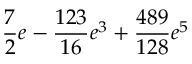Convert formula to latex. <formula><loc_0><loc_0><loc_500><loc_500>\frac { 7 } { 2 } e - \frac { 1 2 3 } { 1 6 } e ^ { 3 } + \frac { 4 8 9 } { 1 2 8 } e ^ { 5 }</formula> 